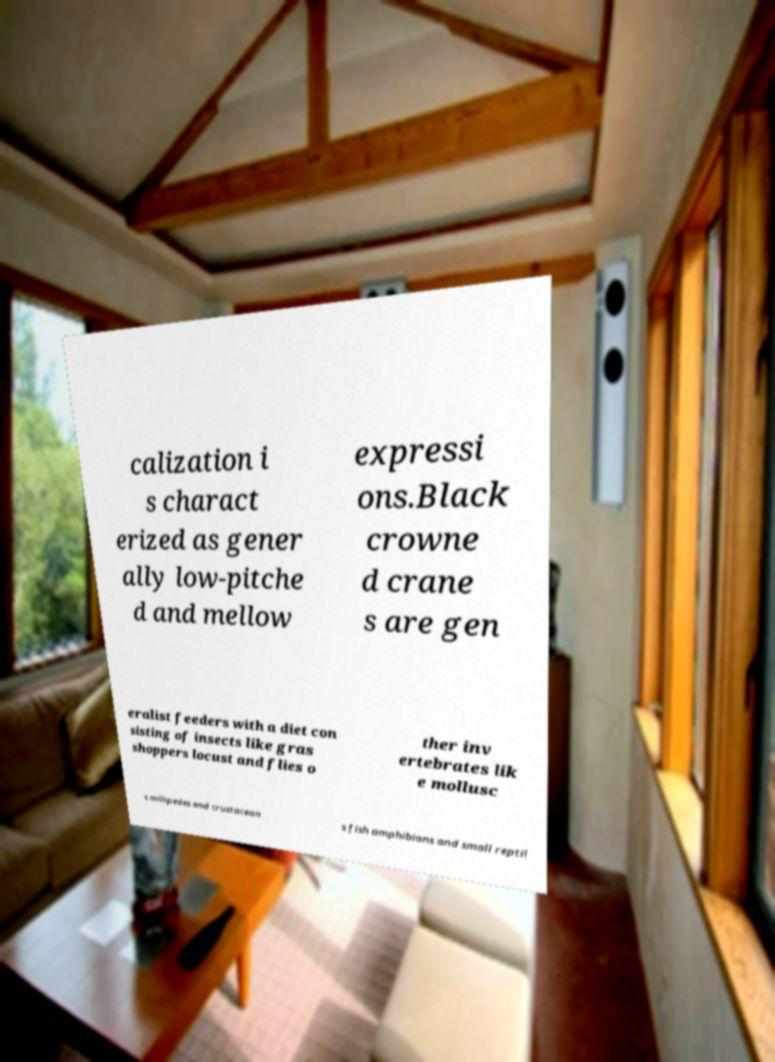Please read and relay the text visible in this image. What does it say? calization i s charact erized as gener ally low-pitche d and mellow expressi ons.Black crowne d crane s are gen eralist feeders with a diet con sisting of insects like gras shoppers locust and flies o ther inv ertebrates lik e mollusc s millipedes and crustacean s fish amphibians and small reptil 